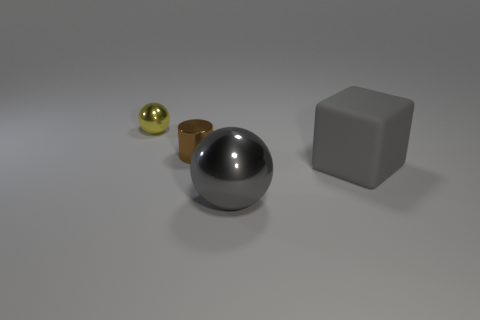There is a thing that is both right of the small cylinder and on the left side of the big block; what shape is it?
Your response must be concise. Sphere. What is the color of the object that is in front of the yellow metal thing and behind the rubber object?
Make the answer very short. Brown. Is the number of tiny metal things to the left of the gray rubber thing greater than the number of small metal objects in front of the large ball?
Provide a succinct answer. Yes. The small metal thing right of the yellow ball is what color?
Keep it short and to the point. Brown. There is a small metal thing that is left of the small shiny cylinder; is its shape the same as the metal thing that is on the right side of the tiny brown cylinder?
Provide a succinct answer. Yes. Is there a metal sphere that has the same size as the cylinder?
Provide a short and direct response. Yes. There is a large gray block that is to the right of the brown shiny object; what is its material?
Your answer should be very brief. Rubber. Are the large gray thing in front of the gray cube and the tiny cylinder made of the same material?
Ensure brevity in your answer.  Yes. Are there any big gray blocks?
Your response must be concise. Yes. There is a large sphere that is made of the same material as the tiny yellow thing; what color is it?
Your response must be concise. Gray. 